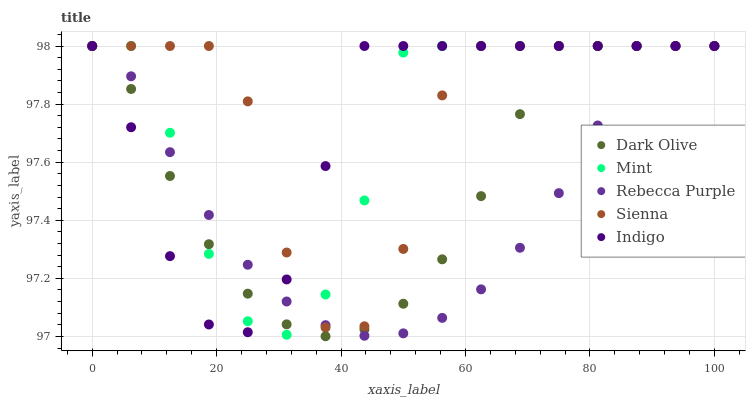Does Rebecca Purple have the minimum area under the curve?
Answer yes or no. Yes. Does Sienna have the maximum area under the curve?
Answer yes or no. Yes. Does Indigo have the minimum area under the curve?
Answer yes or no. No. Does Indigo have the maximum area under the curve?
Answer yes or no. No. Is Rebecca Purple the smoothest?
Answer yes or no. Yes. Is Sienna the roughest?
Answer yes or no. Yes. Is Indigo the smoothest?
Answer yes or no. No. Is Indigo the roughest?
Answer yes or no. No. Does Dark Olive have the lowest value?
Answer yes or no. Yes. Does Indigo have the lowest value?
Answer yes or no. No. Does Rebecca Purple have the highest value?
Answer yes or no. Yes. Does Rebecca Purple intersect Indigo?
Answer yes or no. Yes. Is Rebecca Purple less than Indigo?
Answer yes or no. No. Is Rebecca Purple greater than Indigo?
Answer yes or no. No. 